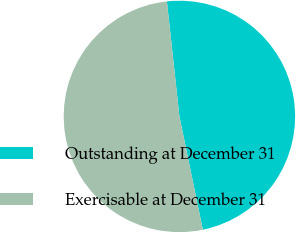Convert chart. <chart><loc_0><loc_0><loc_500><loc_500><pie_chart><fcel>Outstanding at December 31<fcel>Exercisable at December 31<nl><fcel>48.48%<fcel>51.52%<nl></chart> 